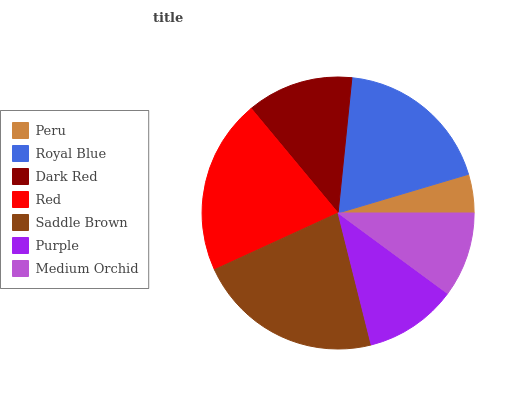Is Peru the minimum?
Answer yes or no. Yes. Is Saddle Brown the maximum?
Answer yes or no. Yes. Is Royal Blue the minimum?
Answer yes or no. No. Is Royal Blue the maximum?
Answer yes or no. No. Is Royal Blue greater than Peru?
Answer yes or no. Yes. Is Peru less than Royal Blue?
Answer yes or no. Yes. Is Peru greater than Royal Blue?
Answer yes or no. No. Is Royal Blue less than Peru?
Answer yes or no. No. Is Dark Red the high median?
Answer yes or no. Yes. Is Dark Red the low median?
Answer yes or no. Yes. Is Red the high median?
Answer yes or no. No. Is Royal Blue the low median?
Answer yes or no. No. 